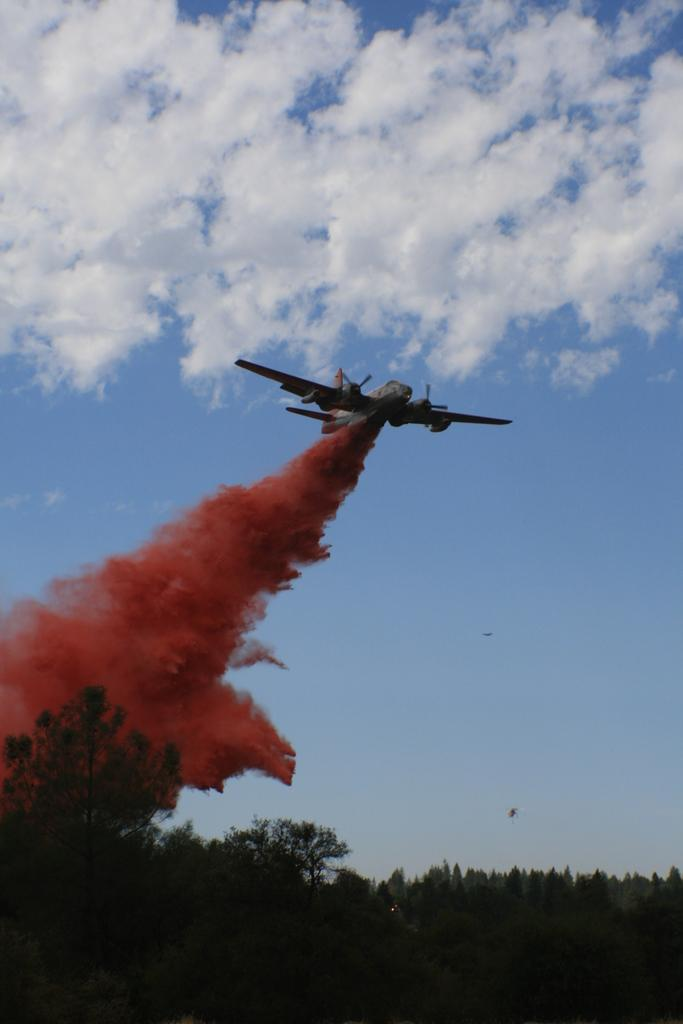What type of natural elements can be seen in the image? There are trees in the image. What is happening in the sky in the image? An aeroplane is flying in the sky. What is the aeroplane doing in the image? The aeroplane is releasing red smoke. What language is being spoken by the trees in the image? Trees do not speak any language, so this cannot be determined from the image. 